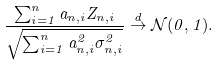<formula> <loc_0><loc_0><loc_500><loc_500>\frac { \sum _ { i = 1 } ^ { n } a _ { n , i } Z _ { n , i } } { \sqrt { \sum _ { i = 1 } ^ { n } a _ { n , i } ^ { 2 } \sigma _ { n , i } ^ { 2 } } } \stackrel { d } { \to } \mathcal { N } ( 0 , 1 ) .</formula> 